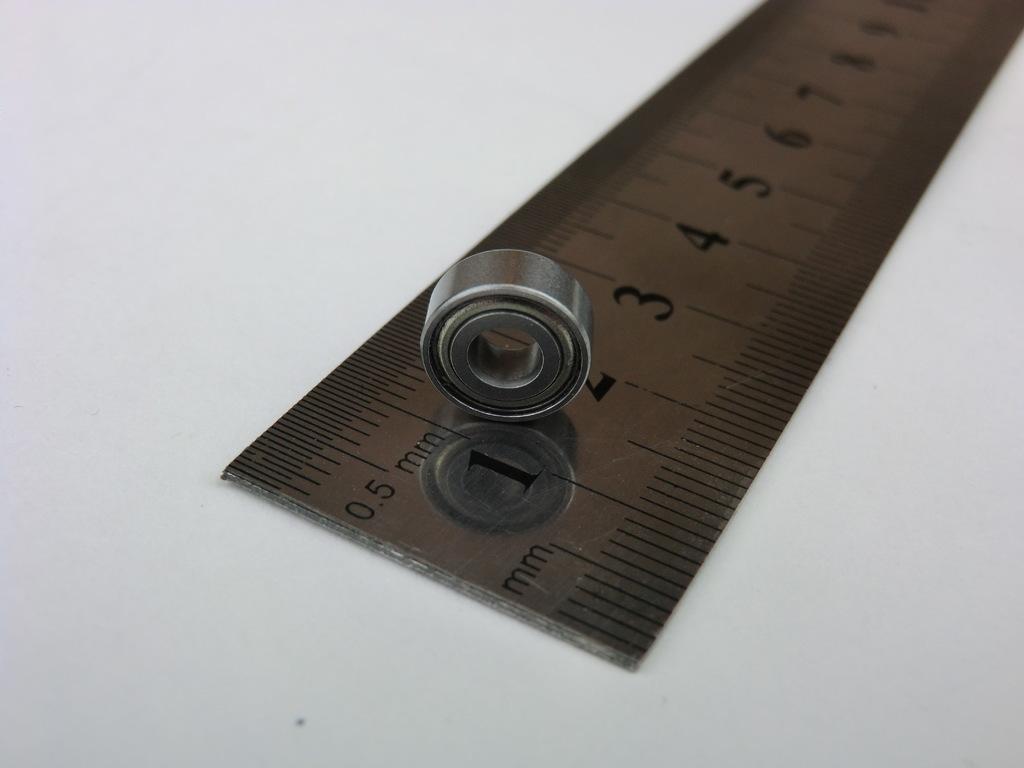Can you describe this image briefly? In this image we can see a scale and one metal which is in circle shape. 